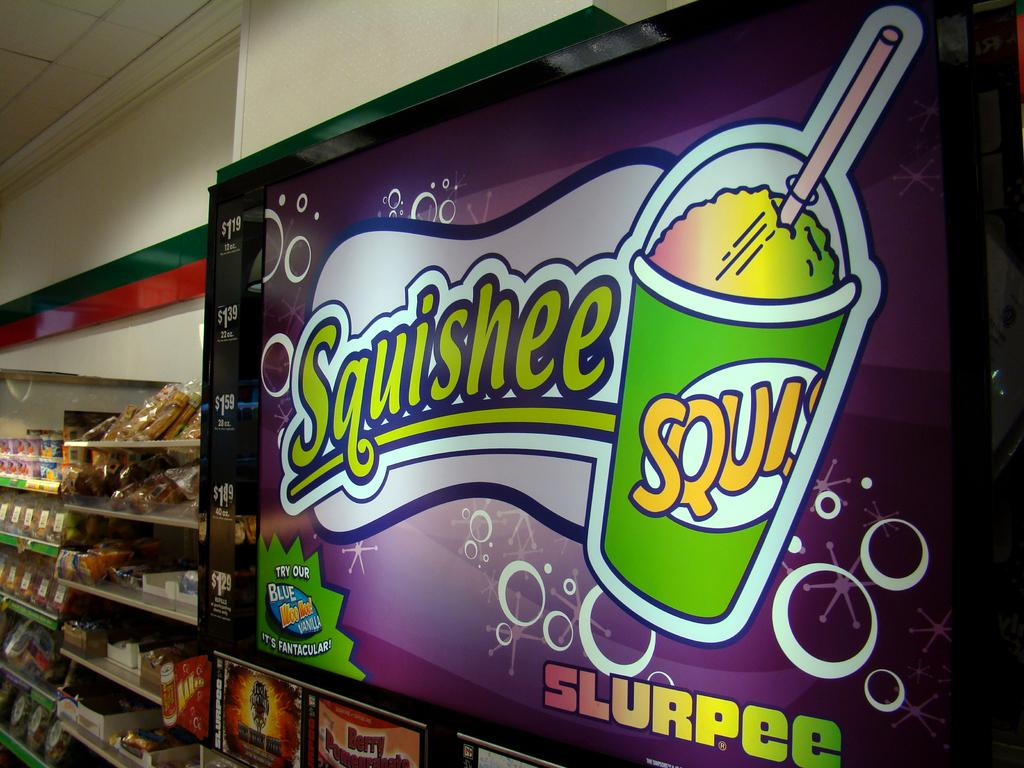<image>
Give a short and clear explanation of the subsequent image. A store that has a sign that says Squishee Slurpee. 